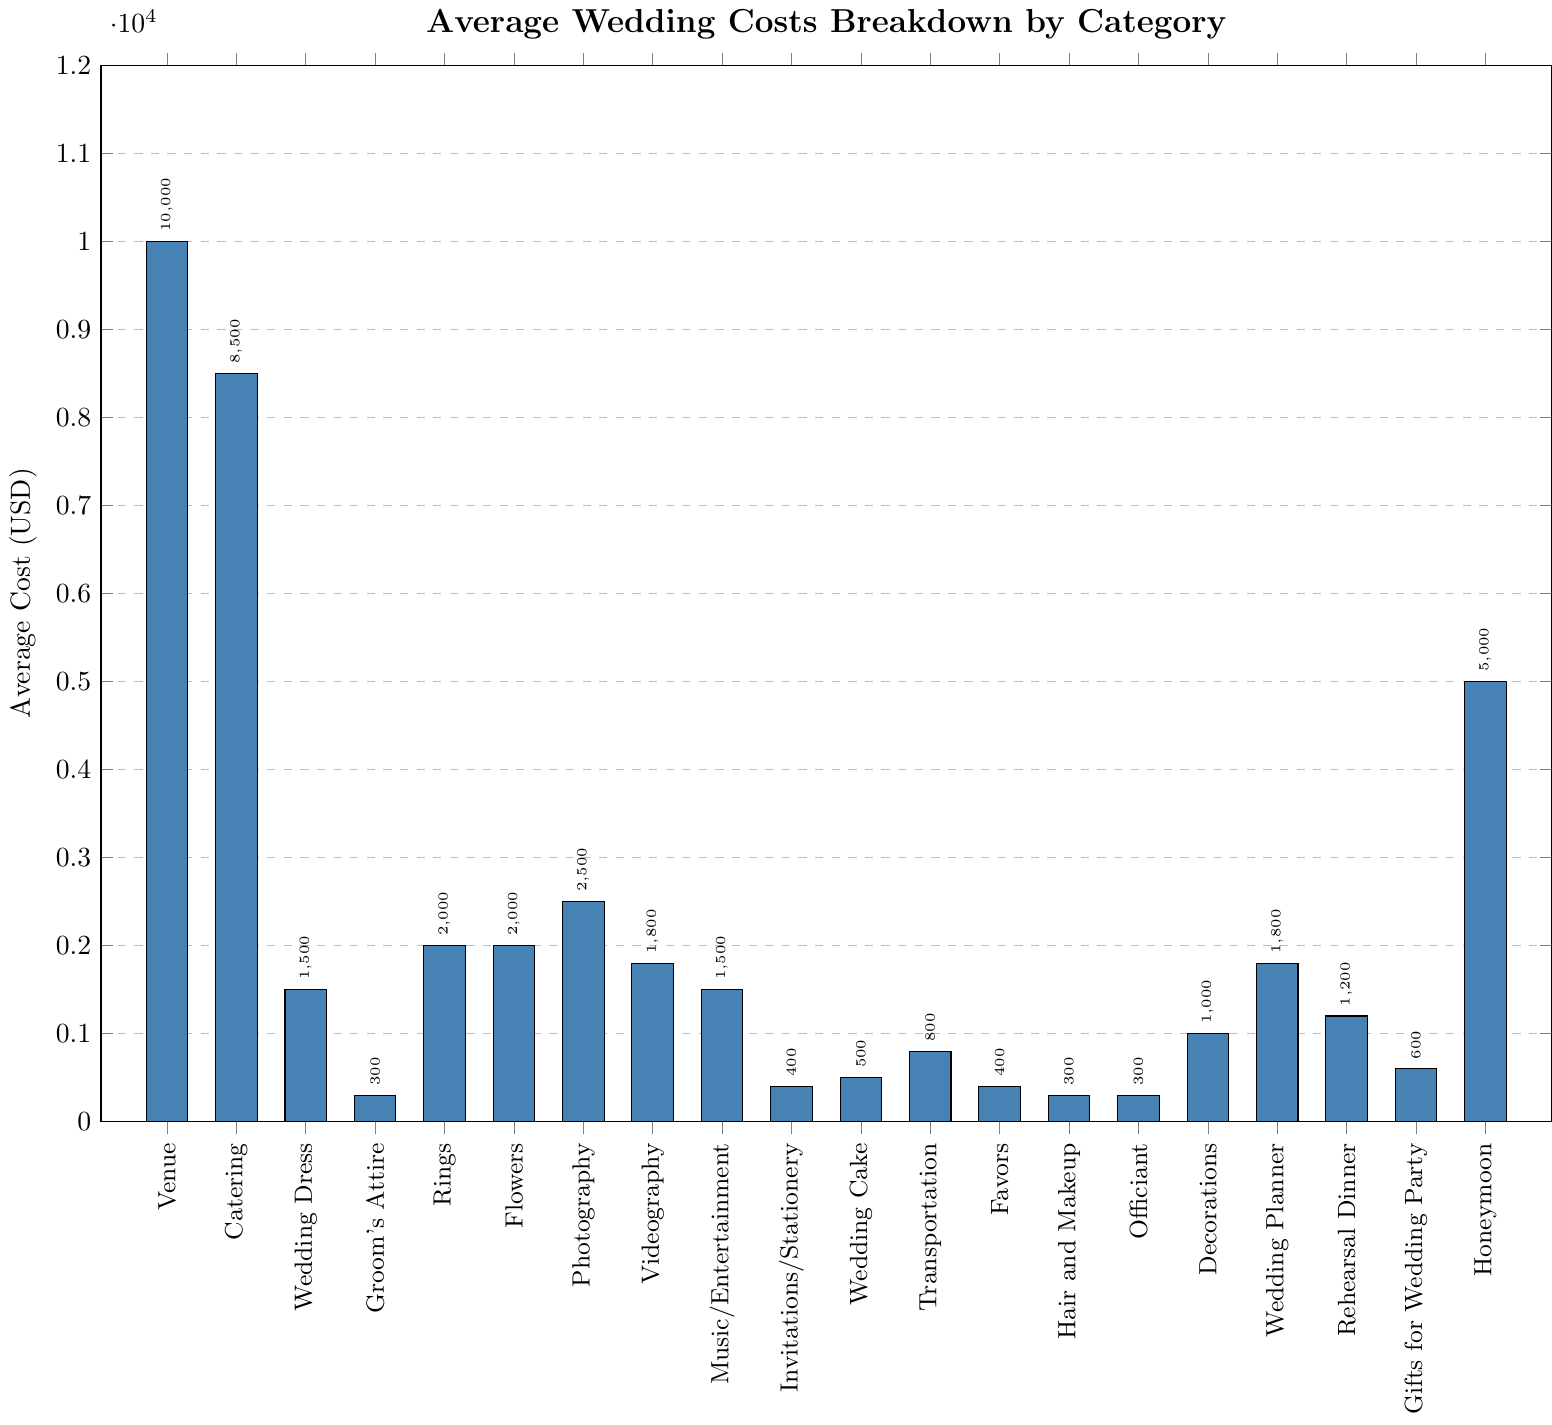What is the most expensive category? The venue has the highest bar, indicating it is the most costly category. It reaches up to $10,000.
Answer: Venue Among rings, flowers, and photography, which category has the highest cost? The bar representing photography is the tallest among the three, showing $2,500. Rings and flowers each have $2,000.
Answer: Photography What is the total average cost of the officiant, hair and makeup, and the groom's attire? Add the values: $300 (Officiant) + $300 (Hair and Makeup) + $300 (Groom's Attire) = $900.
Answer: $900 Which category has a higher average cost, the wedding cake or transportation? The bar for transportation is taller than the one for the wedding cake. Transportation is $800, and the wedding cake is $500.
Answer: Transportation How much more does catering cost than the honeymoon? Catering costs $8,500 while the honeymoon costs $5,000. The difference is $8,500 - $5,000 = $3,500.
Answer: $3,500 If you combine the costs of decorations and the wedding planner, what is the total amount? Decorations cost $1,000 and the wedding planner costs $1,800, so combined they are $1,000 + $1,800 = $2,800.
Answer: $2,800 Which is cheaper: photography or videography? The bar for videography is slightly shorter than for photography. Videography costs $1,800 and photography costs $2,500.
Answer: Videography What is the average cost of catering and the venue? Sum the two values: $8,500 (Catering) + $10,000 (Venue) = $18,500. Divide by 2 to find the average: $18,500 / 2 = $9,250.
Answer: $9,250 Which category is less expensive, invitations/stationery or favors? The bar for invitations/stationery is the same height as the bar for favors; both are $400.
Answer: Equal How much more does the wedding dress cost compared to the groom's attire? The wedding dress costs $1,500 and the groom's attire costs $300. The difference is $1,500 - $300 = $1,200.
Answer: $1,200 